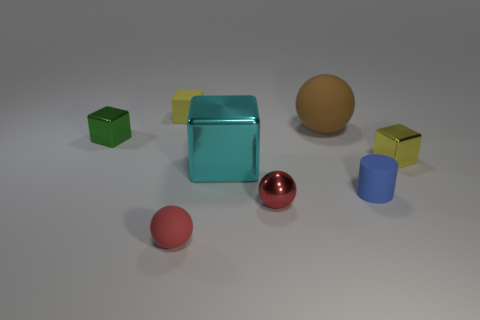What is the shape of the red rubber object? sphere 